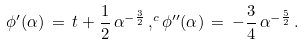Convert formula to latex. <formula><loc_0><loc_0><loc_500><loc_500>\phi ^ { \prime } ( \alpha ) \, = \, t + \frac { 1 } { 2 } \, \alpha ^ { - \frac { 3 } { 2 } } \, , ^ { c } \phi ^ { \prime \prime } ( \alpha ) \, = \, - \frac { 3 } { 4 } \, \alpha ^ { - \frac { 5 } { 2 } } \, .</formula> 